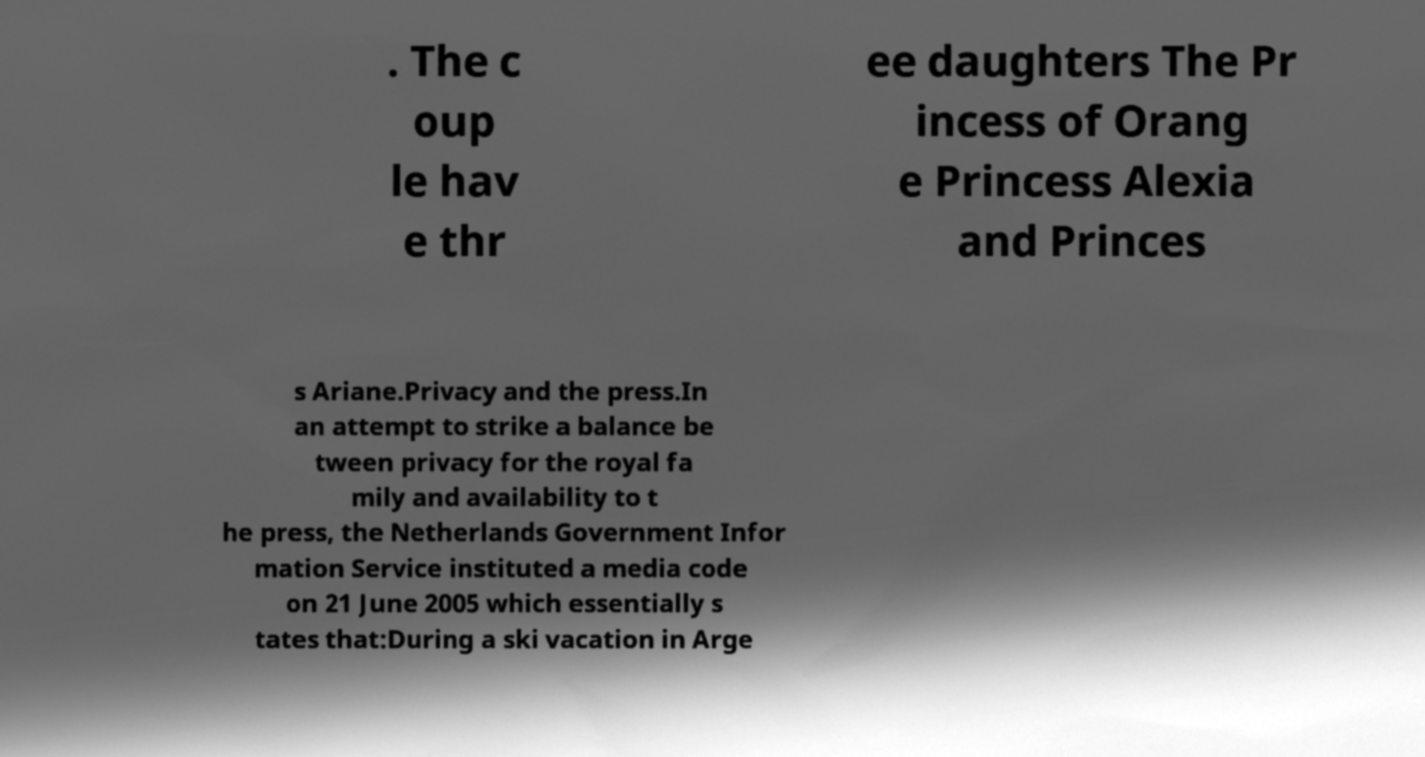Can you read and provide the text displayed in the image?This photo seems to have some interesting text. Can you extract and type it out for me? . The c oup le hav e thr ee daughters The Pr incess of Orang e Princess Alexia and Princes s Ariane.Privacy and the press.In an attempt to strike a balance be tween privacy for the royal fa mily and availability to t he press, the Netherlands Government Infor mation Service instituted a media code on 21 June 2005 which essentially s tates that:During a ski vacation in Arge 